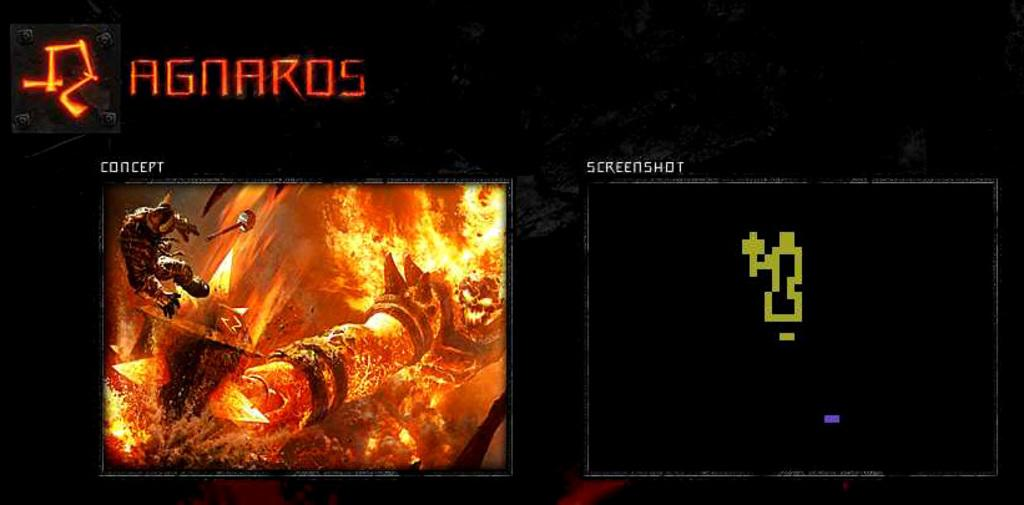<image>
Present a compact description of the photo's key features. Two boxes are on a black display, one of which is labeled "concept" and the other "screenshot". 